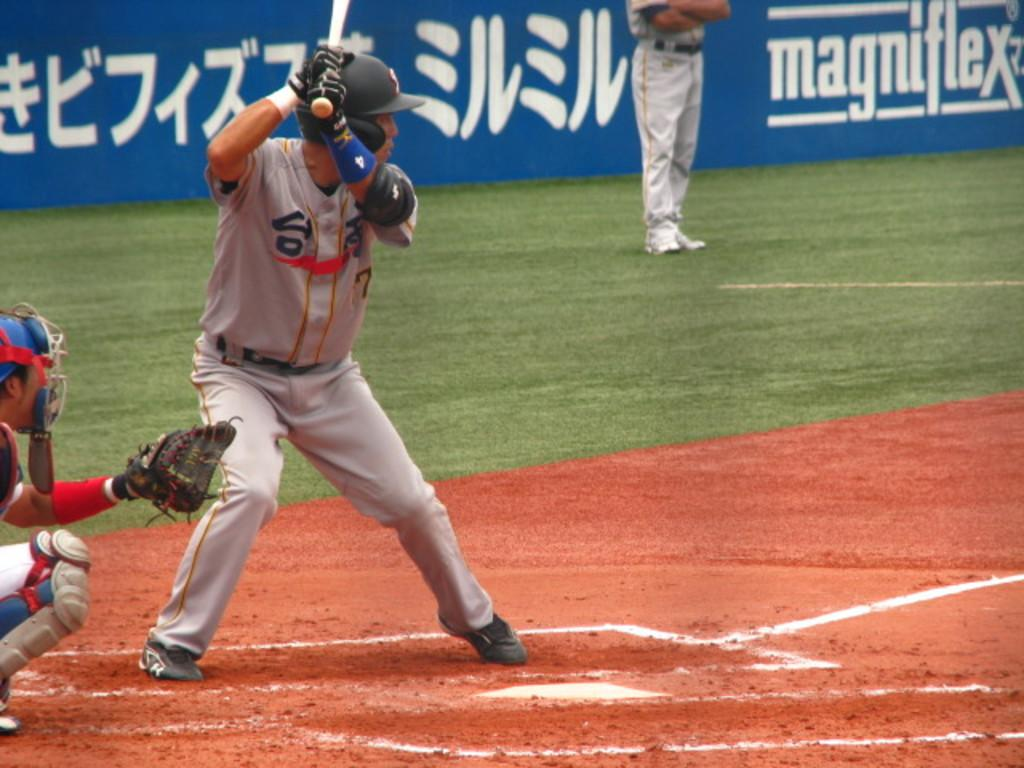Provide a one-sentence caption for the provided image. A batter is in position with his helmet on in front of an ad for magniflex. 